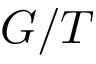<formula> <loc_0><loc_0><loc_500><loc_500>G / T</formula> 